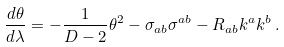Convert formula to latex. <formula><loc_0><loc_0><loc_500><loc_500>\frac { d \theta } { d \lambda } = - \frac { 1 } { D - 2 } \theta ^ { 2 } - \sigma _ { a b } \sigma ^ { a b } - R _ { a b } k ^ { a } k ^ { b } \, .</formula> 